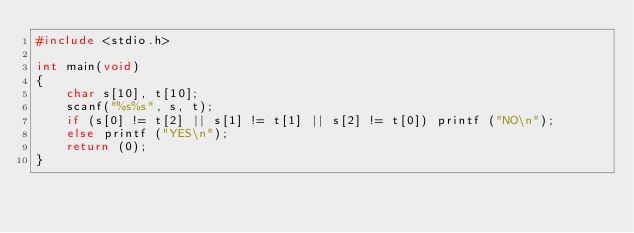<code> <loc_0><loc_0><loc_500><loc_500><_C_>#include <stdio.h>

int main(void)
{
    char s[10], t[10];
    scanf("%s%s", s, t);
    if (s[0] != t[2] || s[1] != t[1] || s[2] != t[0]) printf ("NO\n");
    else printf ("YES\n");
    return (0);
}
</code> 